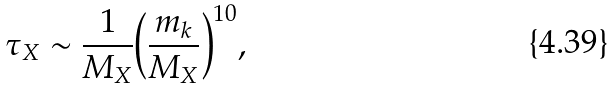Convert formula to latex. <formula><loc_0><loc_0><loc_500><loc_500>\tau _ { X } \sim \frac { 1 } { M _ { X } } { \left ( \frac { m _ { k } } { M _ { X } } \right ) } ^ { 1 0 } ,</formula> 